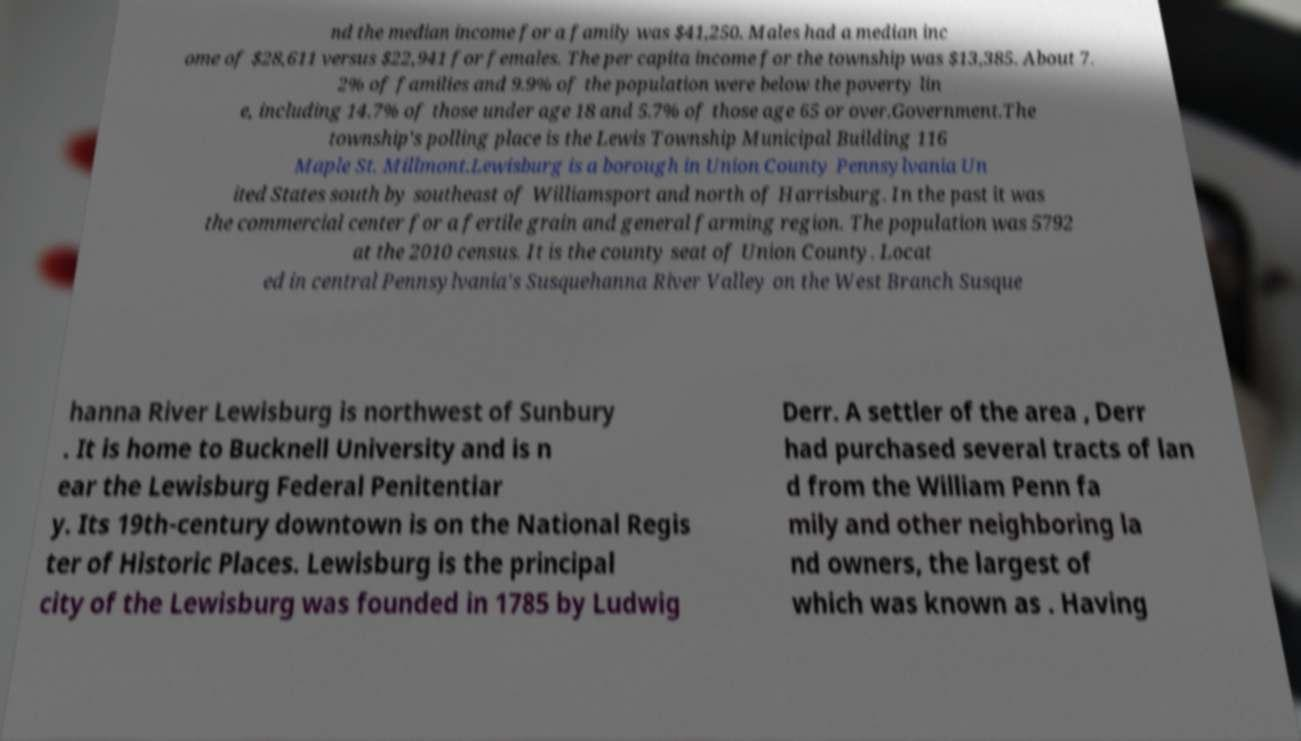Could you assist in decoding the text presented in this image and type it out clearly? nd the median income for a family was $41,250. Males had a median inc ome of $28,611 versus $22,941 for females. The per capita income for the township was $13,385. About 7. 2% of families and 9.9% of the population were below the poverty lin e, including 14.7% of those under age 18 and 5.7% of those age 65 or over.Government.The township's polling place is the Lewis Township Municipal Building 116 Maple St. Millmont.Lewisburg is a borough in Union County Pennsylvania Un ited States south by southeast of Williamsport and north of Harrisburg. In the past it was the commercial center for a fertile grain and general farming region. The population was 5792 at the 2010 census. It is the county seat of Union County. Locat ed in central Pennsylvania's Susquehanna River Valley on the West Branch Susque hanna River Lewisburg is northwest of Sunbury . It is home to Bucknell University and is n ear the Lewisburg Federal Penitentiar y. Its 19th-century downtown is on the National Regis ter of Historic Places. Lewisburg is the principal city of the Lewisburg was founded in 1785 by Ludwig Derr. A settler of the area , Derr had purchased several tracts of lan d from the William Penn fa mily and other neighboring la nd owners, the largest of which was known as . Having 